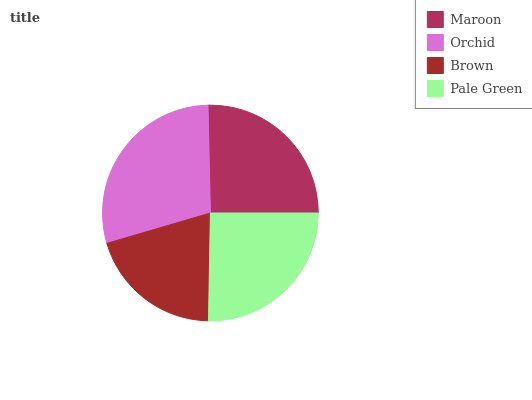Is Brown the minimum?
Answer yes or no. Yes. Is Orchid the maximum?
Answer yes or no. Yes. Is Orchid the minimum?
Answer yes or no. No. Is Brown the maximum?
Answer yes or no. No. Is Orchid greater than Brown?
Answer yes or no. Yes. Is Brown less than Orchid?
Answer yes or no. Yes. Is Brown greater than Orchid?
Answer yes or no. No. Is Orchid less than Brown?
Answer yes or no. No. Is Maroon the high median?
Answer yes or no. Yes. Is Pale Green the low median?
Answer yes or no. Yes. Is Pale Green the high median?
Answer yes or no. No. Is Brown the low median?
Answer yes or no. No. 